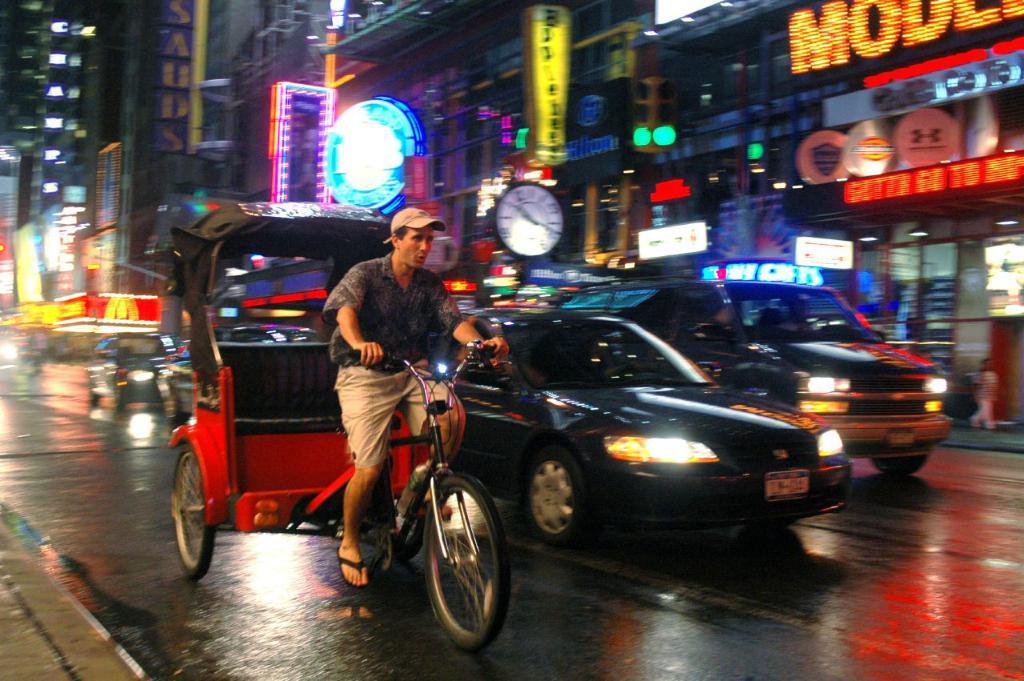What's the first letter of the sign on the right?
Your answer should be compact. M. What is the letter in yellow towards the background?
Offer a very short reply. M. 